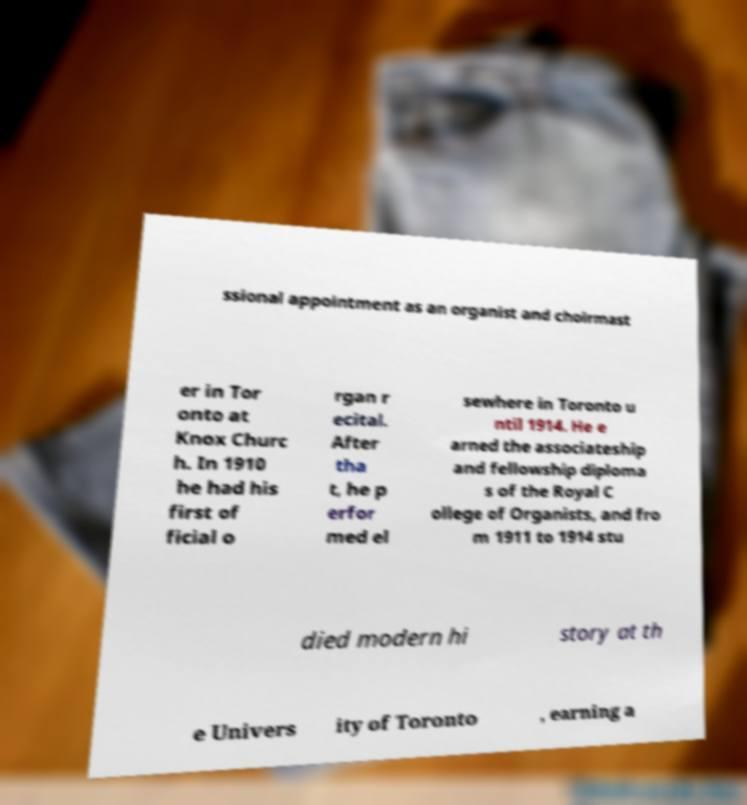Please identify and transcribe the text found in this image. ssional appointment as an organist and choirmast er in Tor onto at Knox Churc h. In 1910 he had his first of ficial o rgan r ecital. After tha t, he p erfor med el sewhere in Toronto u ntil 1914. He e arned the associateship and fellowship diploma s of the Royal C ollege of Organists, and fro m 1911 to 1914 stu died modern hi story at th e Univers ity of Toronto , earning a 